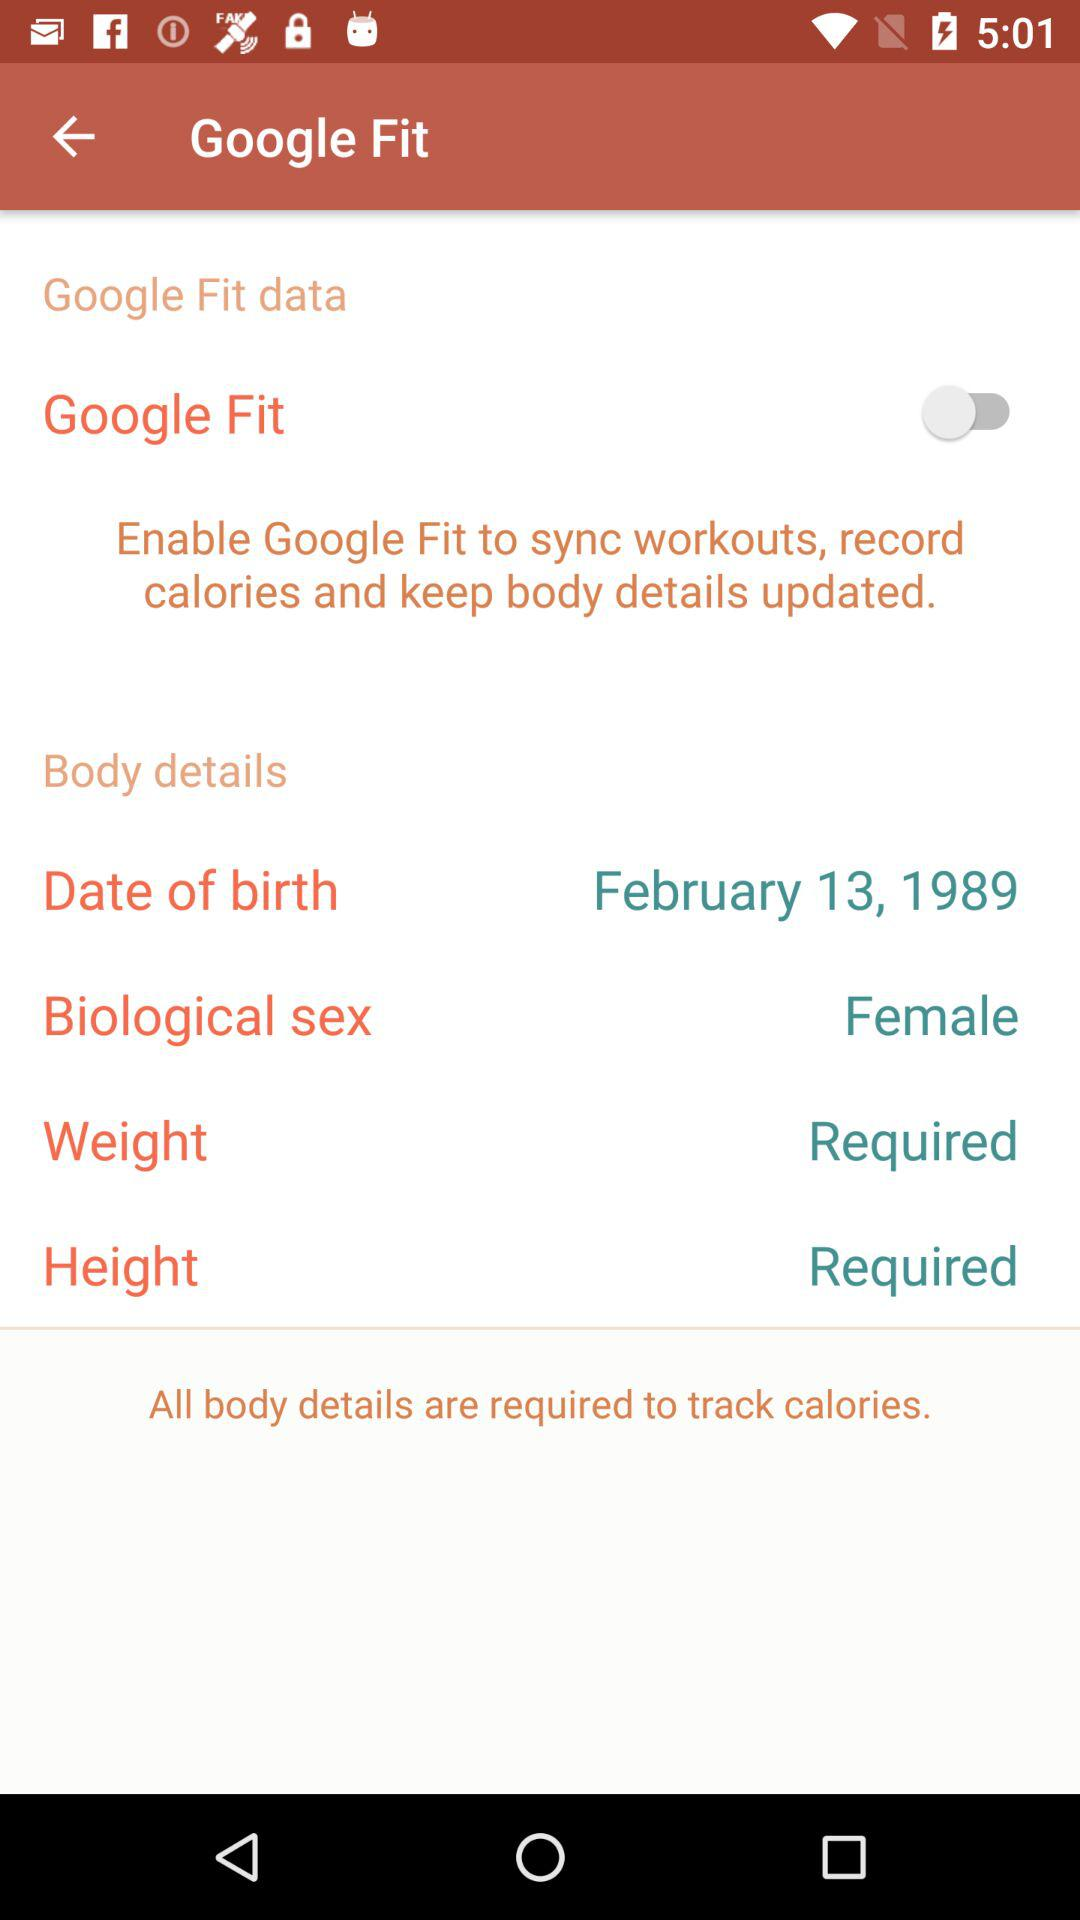How many body details are required to track calories?
Answer the question using a single word or phrase. 4 